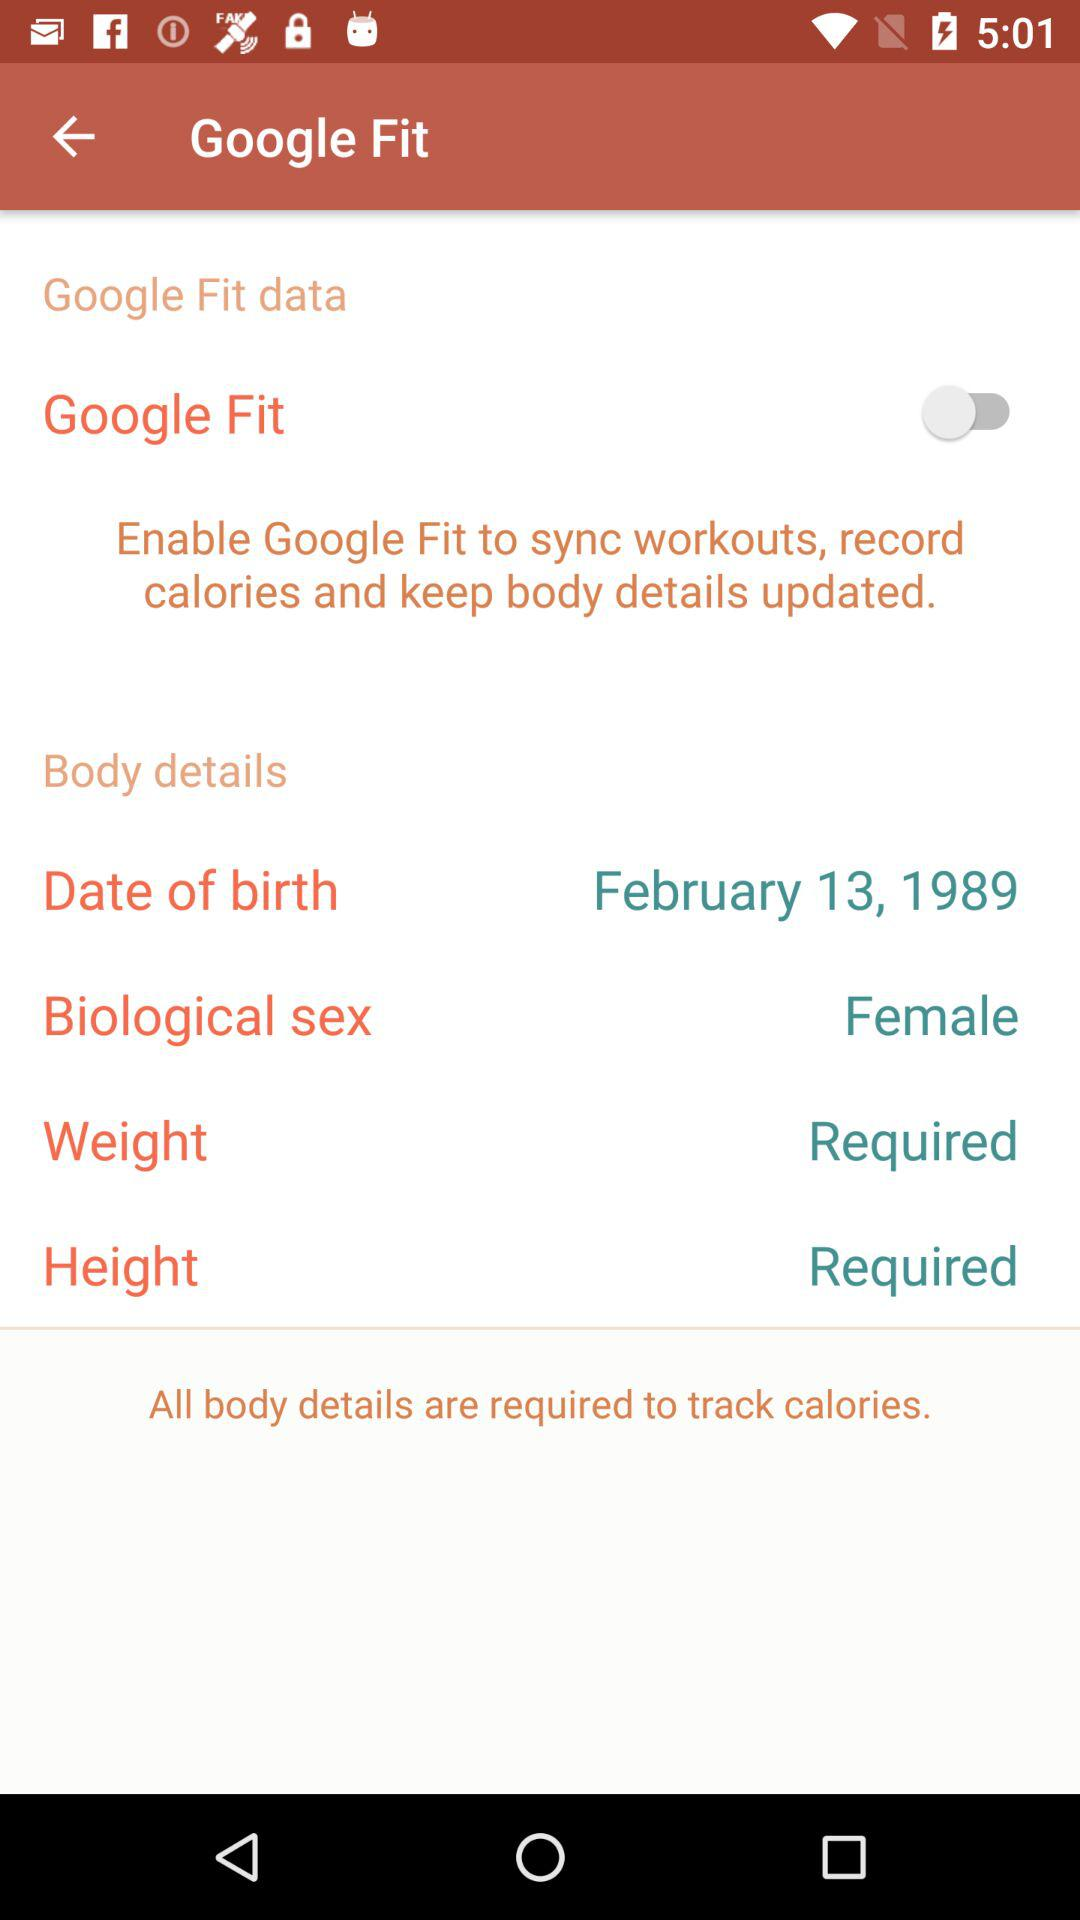How many body details are required to track calories?
Answer the question using a single word or phrase. 4 